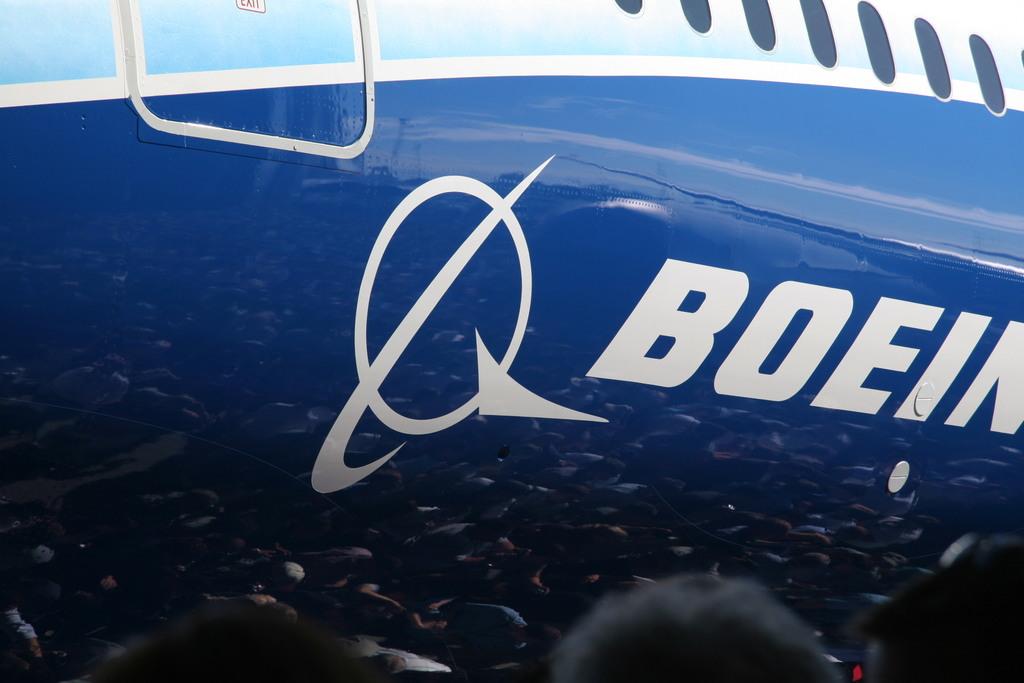What is the brand name on the plane?
Ensure brevity in your answer.  Boeing. This is areplain?
Keep it short and to the point. Yes. 